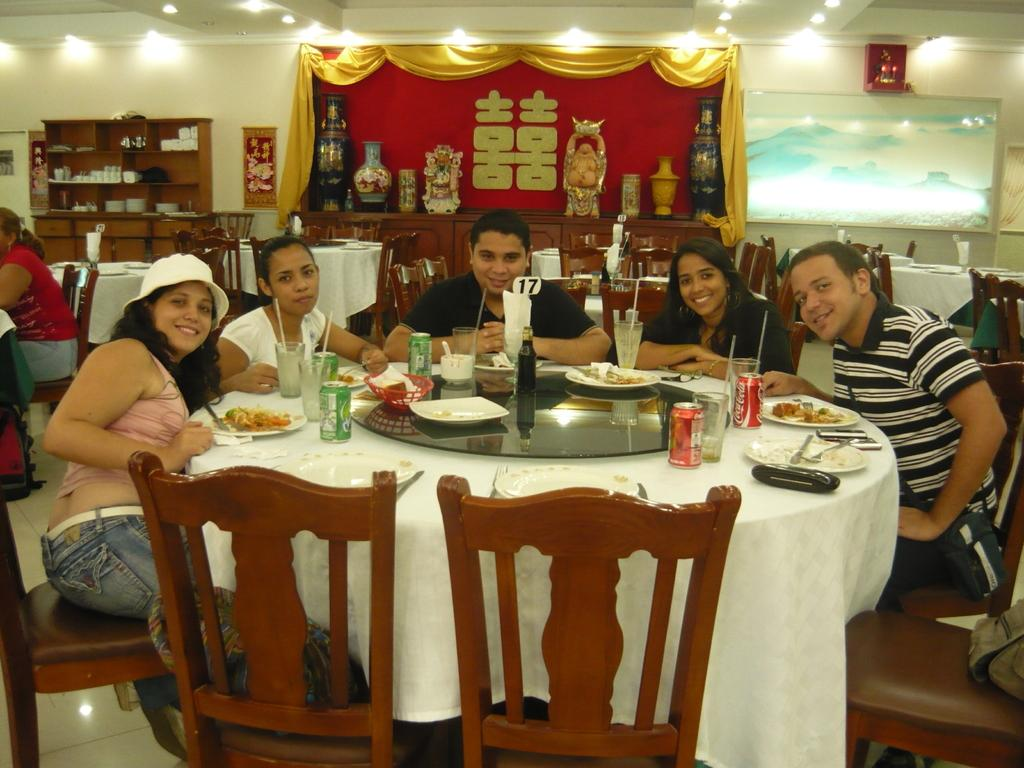How many people are present in the image? There are five people in the image. What are the people doing in the image? The people are sitting on chairs. How are the chairs arranged in the image? The chairs are arranged around a table. What can be found on the table in the image? There are things placed on the table. What other furniture can be seen in the background of the image? There are additional chairs and tables visible in the background. Can you describe any other features in the background of the image? There is a shelf in the background. What type of potato is being prepared by the manager in the image? There is no potato or manager present in the image. What type of camp can be seen in the background of the image? There is no camp visible in the image; it features a group of people sitting around a table with additional chairs and tables in the background. 